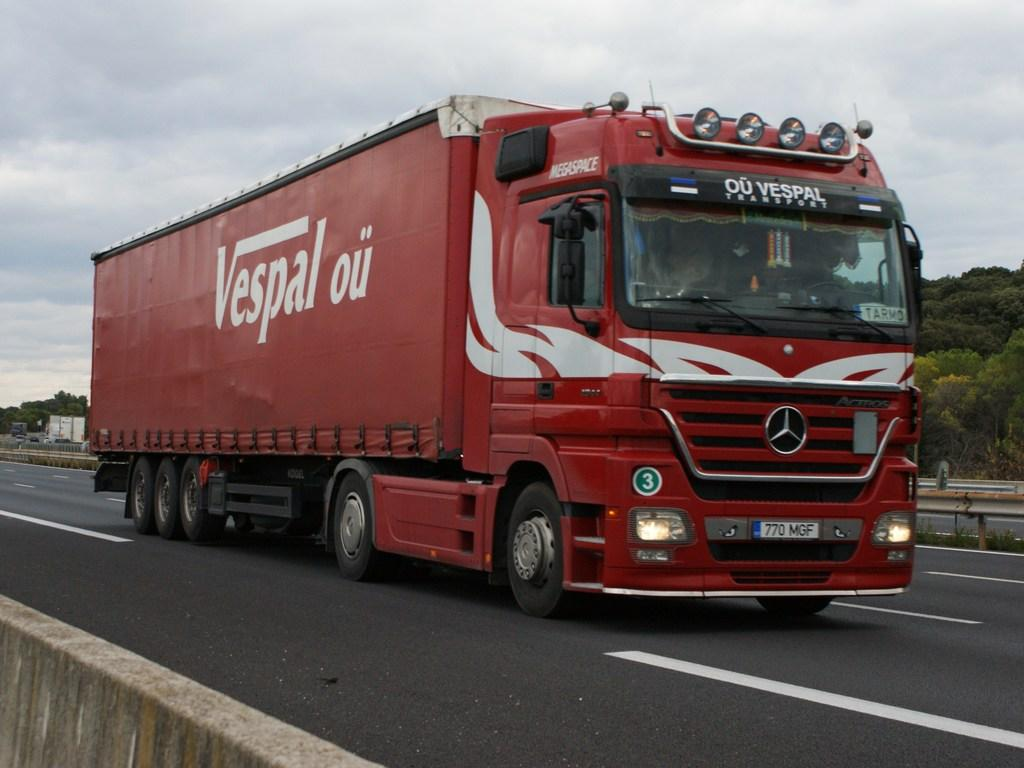What type of vehicle is in the image? There is a red color truck in the image. Where is the truck located? The truck is on the road. What can be seen in the background of the image? There is a fence, trees, and clouds visible in the background of the image. How many chairs are placed around the truck in the image? There are no chairs present in the image. What type of feet does the truck have in the image? Trucks do not have feet; they have wheels. 